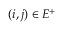<formula> <loc_0><loc_0><loc_500><loc_500>( i , j ) \in E ^ { + }</formula> 